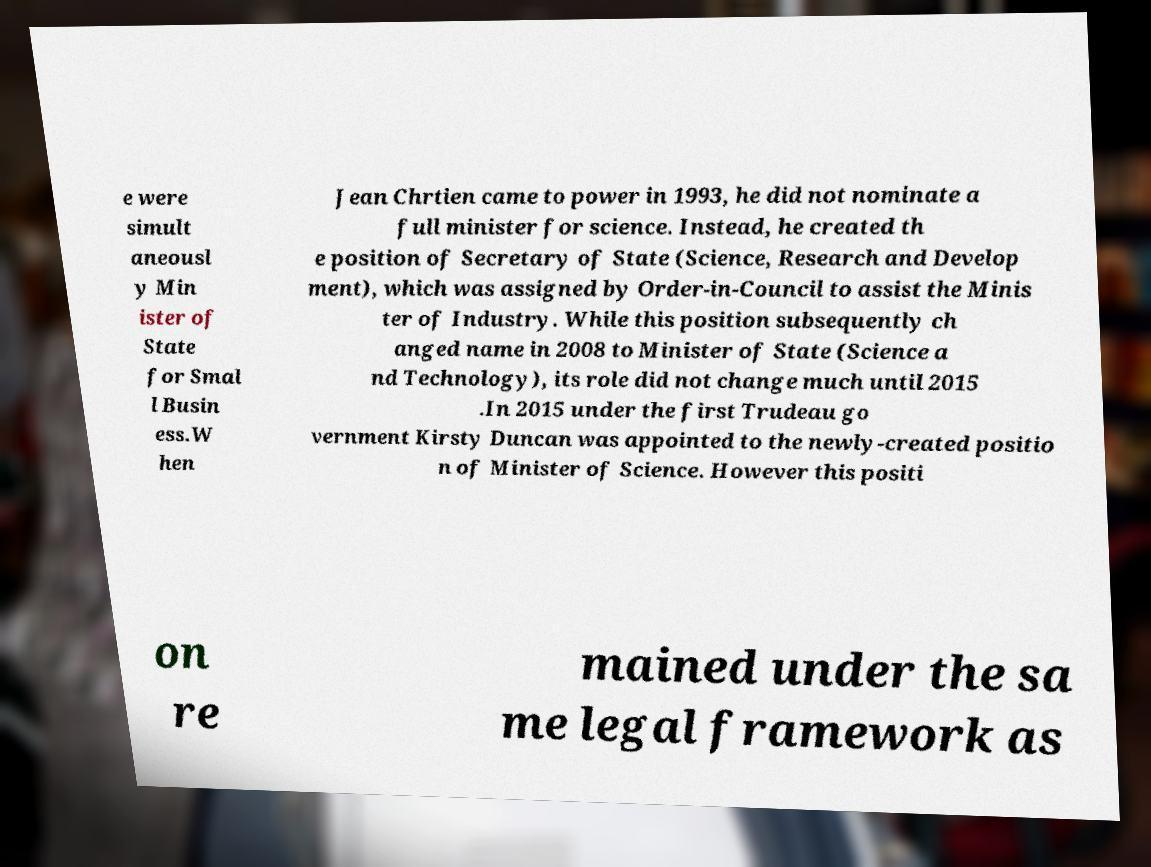What messages or text are displayed in this image? I need them in a readable, typed format. e were simult aneousl y Min ister of State for Smal l Busin ess.W hen Jean Chrtien came to power in 1993, he did not nominate a full minister for science. Instead, he created th e position of Secretary of State (Science, Research and Develop ment), which was assigned by Order-in-Council to assist the Minis ter of Industry. While this position subsequently ch anged name in 2008 to Minister of State (Science a nd Technology), its role did not change much until 2015 .In 2015 under the first Trudeau go vernment Kirsty Duncan was appointed to the newly-created positio n of Minister of Science. However this positi on re mained under the sa me legal framework as 